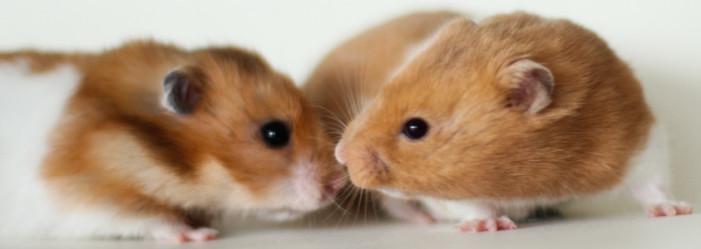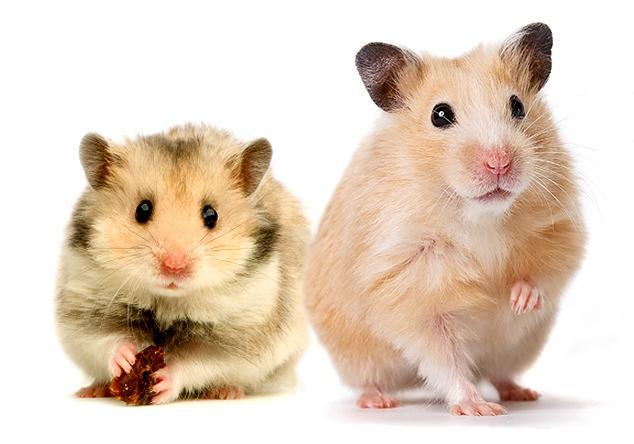The first image is the image on the left, the second image is the image on the right. Considering the images on both sides, is "In one of the images, there is an orange food item being eaten." valid? Answer yes or no. No. The first image is the image on the left, the second image is the image on the right. Given the left and right images, does the statement "There are fewer than four hamsters." hold true? Answer yes or no. No. 